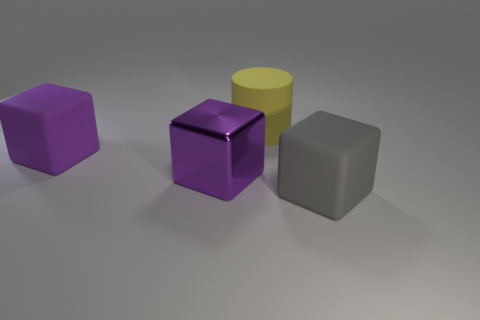Are there any patterns or textures on the objects that stand out to you? Most of the objects have a smooth texture, particularly the cubes and the cylinder. The purple metal cube has a reflective property, showing both the environment and highlights from the light source, which distinguishes it from the matte finish of the other objects. How do the objects' colors contribute to the overall aesthetic of the image? The objects' colors are primarily cool tones, with the purple cubes providing a sense of uniformity. Meanwhile, the yellow cylinder adds a contrasting pop of color that draws the eye, breaking the monotony and adding visual interest. 